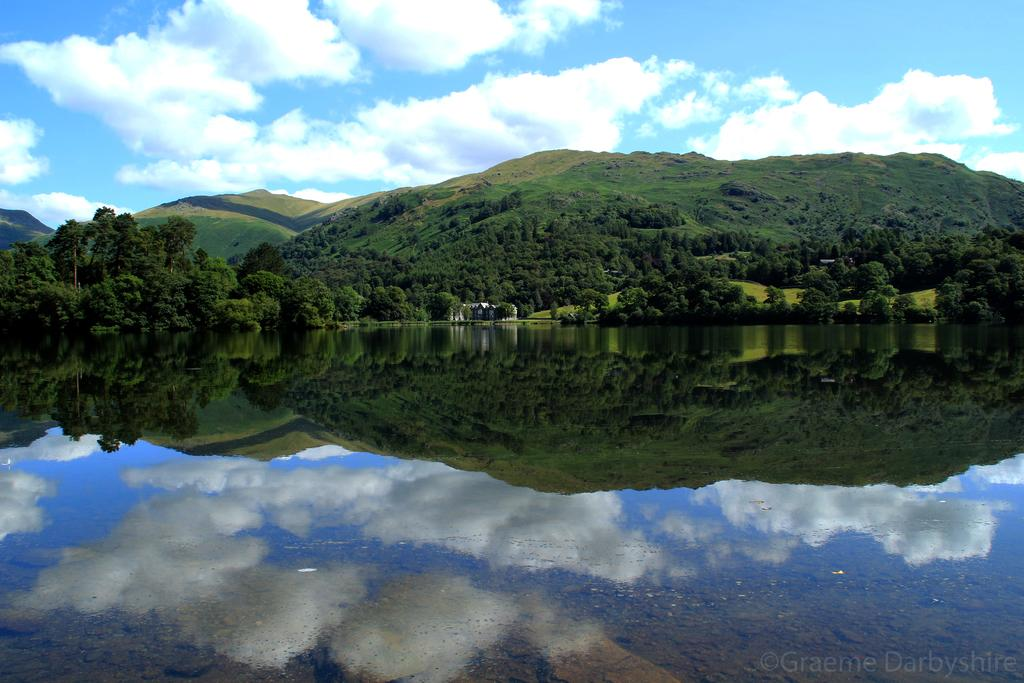What is visible in the image? Water, trees, hills, and clouds are visible in the image. Can you describe the landscape in the image? The landscape in the image includes water, trees, and hills. What is the weather like in the image? The presence of clouds suggests that the weather might be partly cloudy. What type of brick is being used to construct the government building in the image? There is no government building or brick present in the image. 